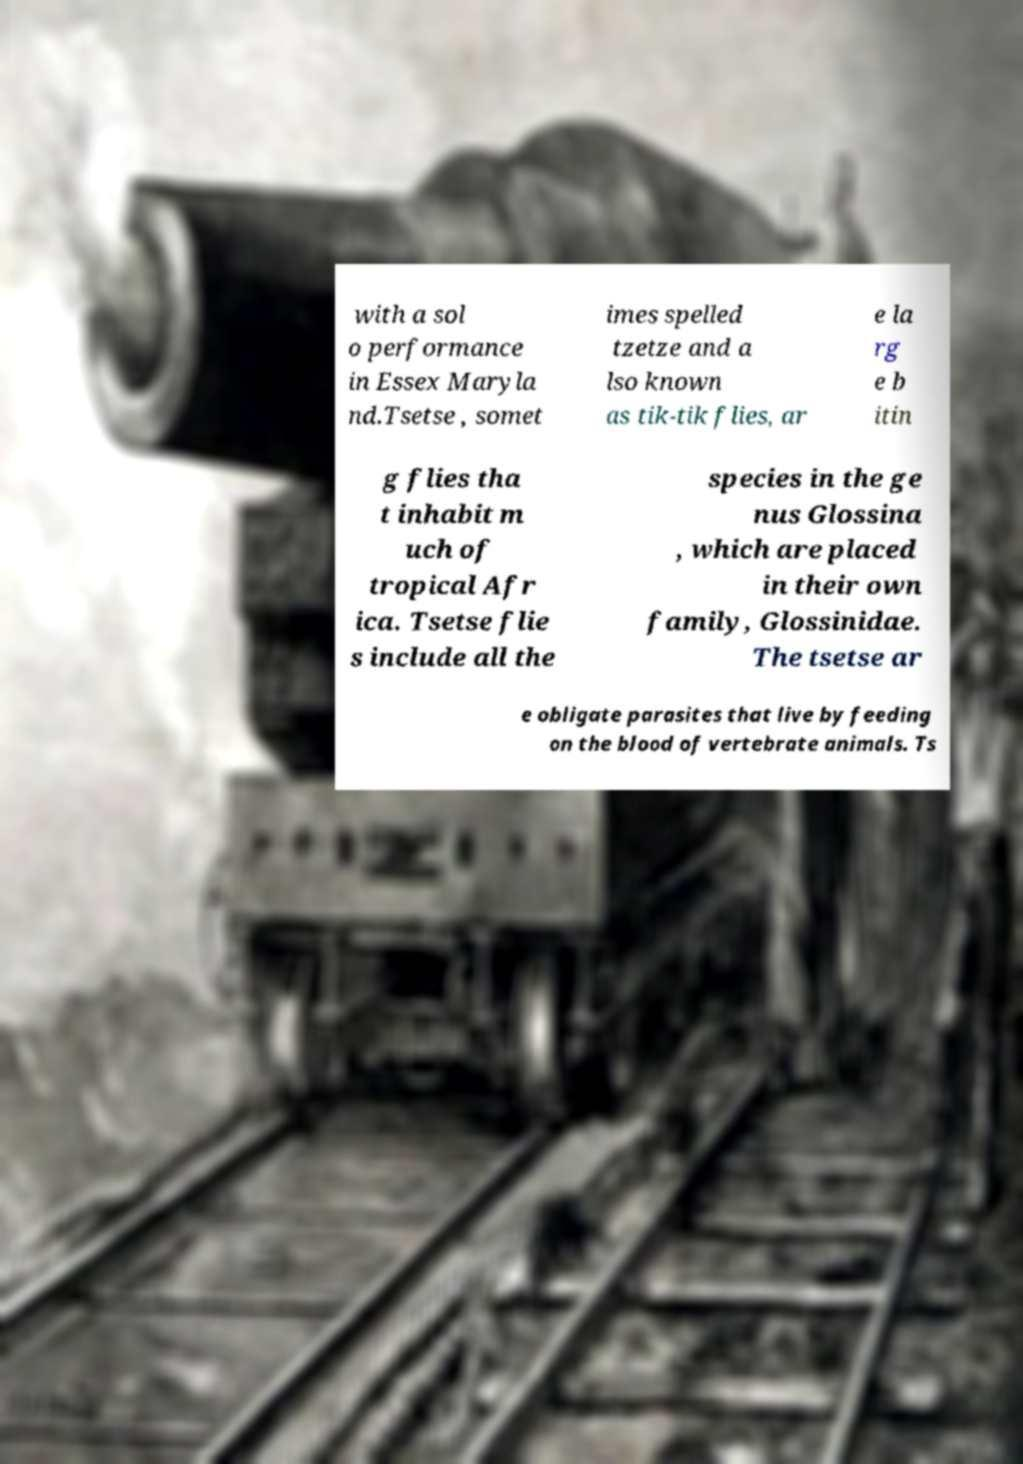Can you read and provide the text displayed in the image?This photo seems to have some interesting text. Can you extract and type it out for me? with a sol o performance in Essex Maryla nd.Tsetse , somet imes spelled tzetze and a lso known as tik-tik flies, ar e la rg e b itin g flies tha t inhabit m uch of tropical Afr ica. Tsetse flie s include all the species in the ge nus Glossina , which are placed in their own family, Glossinidae. The tsetse ar e obligate parasites that live by feeding on the blood of vertebrate animals. Ts 